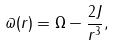Convert formula to latex. <formula><loc_0><loc_0><loc_500><loc_500>\varpi ( r ) = \Omega - \frac { 2 J } { r ^ { 3 } } ,</formula> 